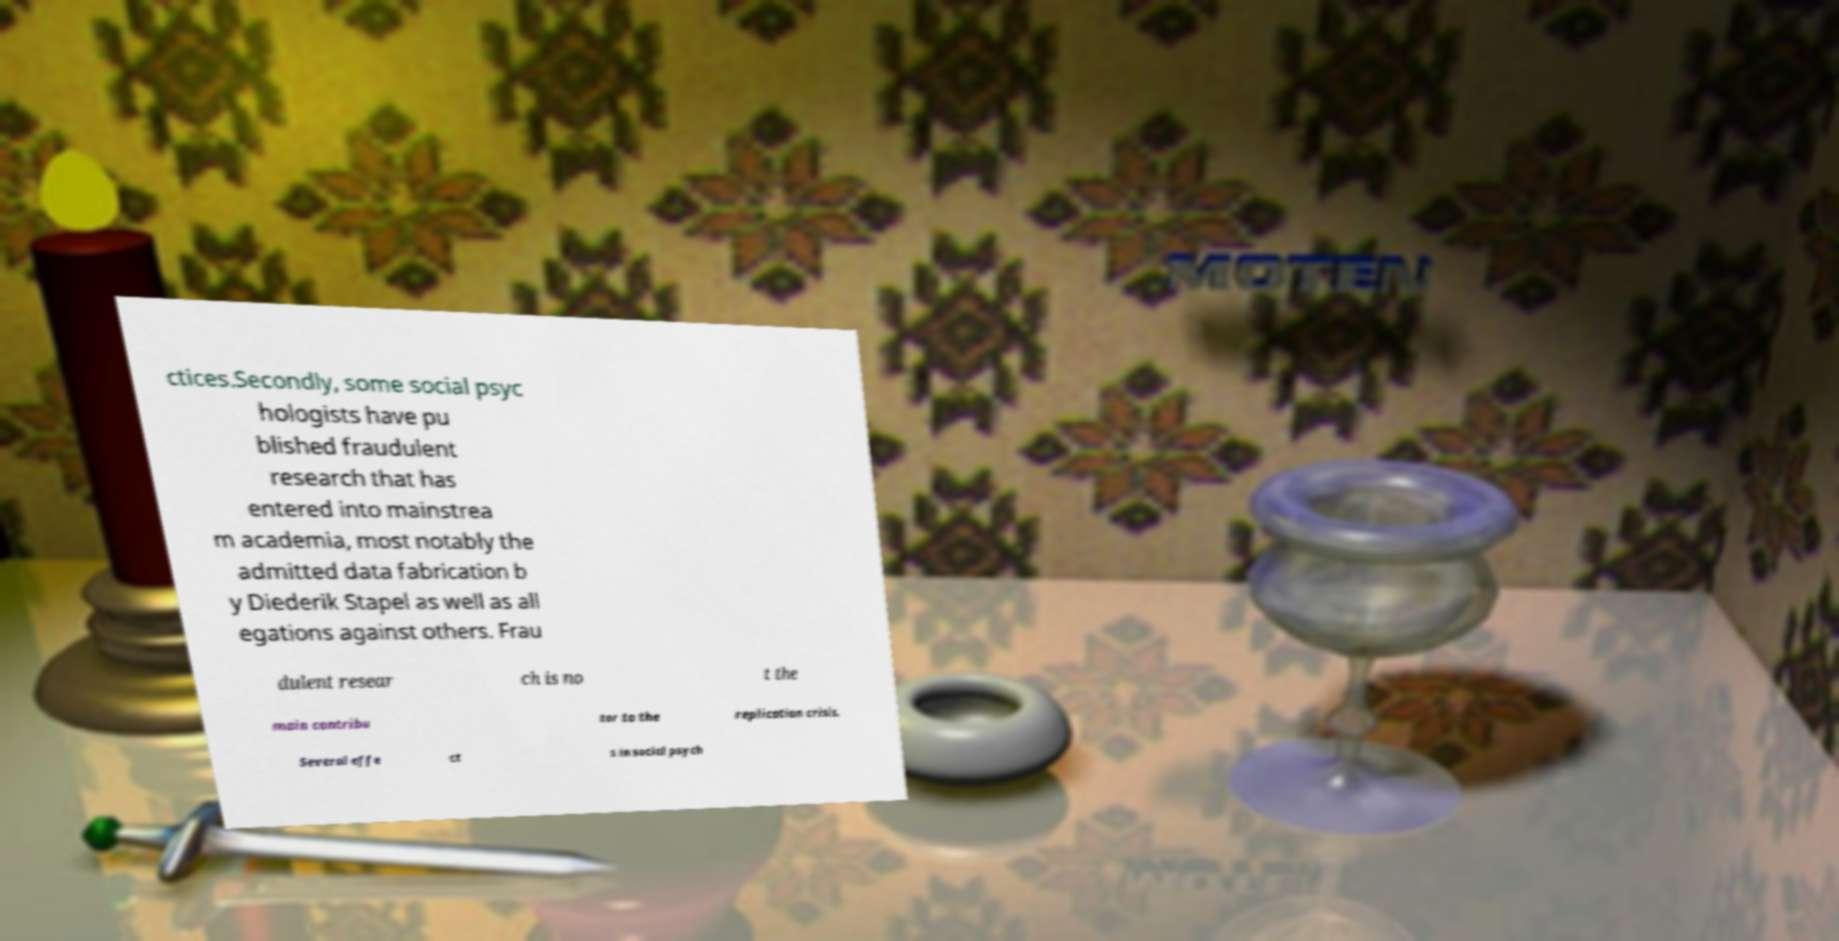Could you assist in decoding the text presented in this image and type it out clearly? ctices.Secondly, some social psyc hologists have pu blished fraudulent research that has entered into mainstrea m academia, most notably the admitted data fabrication b y Diederik Stapel as well as all egations against others. Frau dulent resear ch is no t the main contribu tor to the replication crisis. Several effe ct s in social psych 